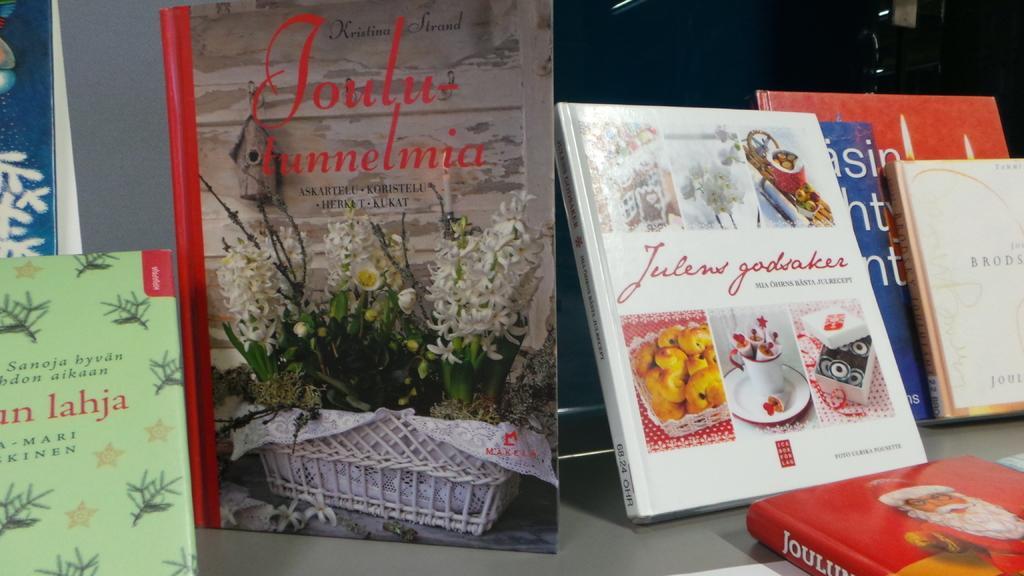Could you give a brief overview of what you see in this image? In this image there are books on the table. There are pictures and text on the books. In the center there is a book. On the book there is picture of a flower pot. Beside it there is another book. On that book there are pictures of a cup and saucer, a box and food. 